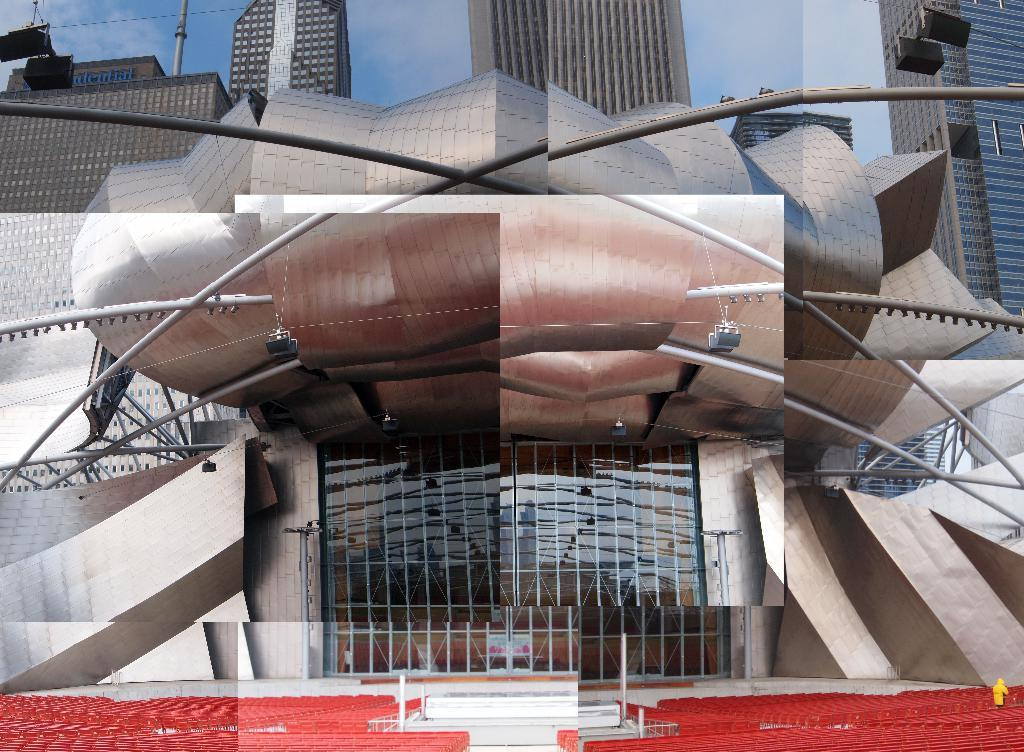What type of structure is in the image? There is a building in the image. What is unique about the building? The building has a flower structure. What else can be seen in the background of the image? There are other buildings visible in the background. What is visible at the top of the image? The sky is visible at the top of the image. What is attached to the wire in the left top part of the image? There are lights attached to a wire in the left top part of the image. How many flowers are being crushed by the building in the image? There are no flowers being crushed by the building in the image. What is the building trying to stop in the image? The building is not trying to stop anything in the image; it is a stationary structure. 